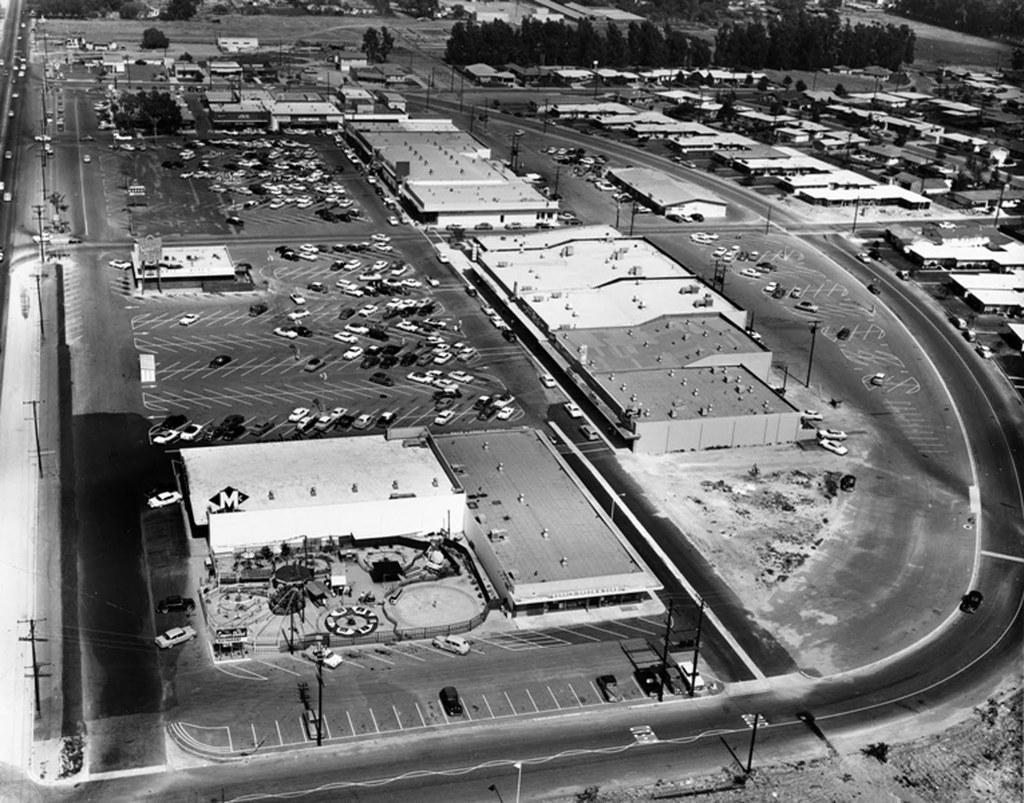In one or two sentences, can you explain what this image depicts? In this image there are cars, poles there are buildings and trees. 